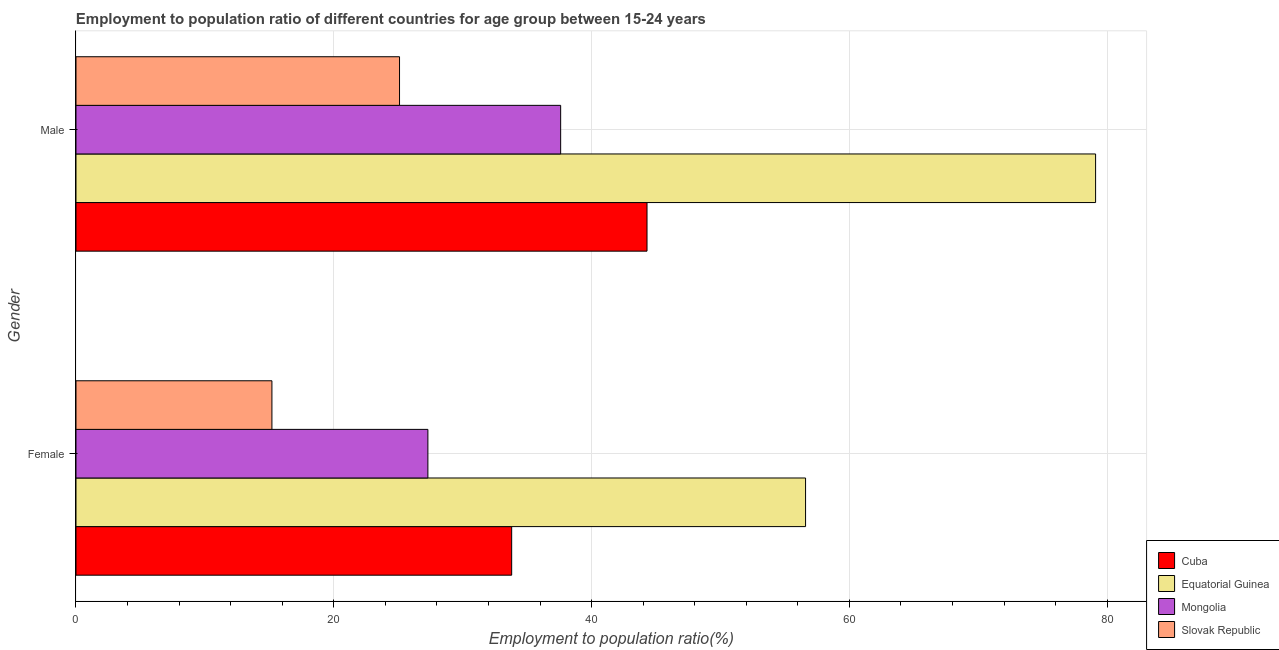How many groups of bars are there?
Provide a succinct answer. 2. How many bars are there on the 1st tick from the top?
Offer a terse response. 4. What is the employment to population ratio(female) in Cuba?
Offer a very short reply. 33.8. Across all countries, what is the maximum employment to population ratio(male)?
Make the answer very short. 79.1. Across all countries, what is the minimum employment to population ratio(male)?
Keep it short and to the point. 25.1. In which country was the employment to population ratio(female) maximum?
Your answer should be very brief. Equatorial Guinea. In which country was the employment to population ratio(male) minimum?
Make the answer very short. Slovak Republic. What is the total employment to population ratio(male) in the graph?
Your response must be concise. 186.1. What is the difference between the employment to population ratio(female) in Mongolia and that in Cuba?
Offer a terse response. -6.5. What is the difference between the employment to population ratio(male) in Mongolia and the employment to population ratio(female) in Equatorial Guinea?
Keep it short and to the point. -19. What is the average employment to population ratio(female) per country?
Your response must be concise. 33.22. What is the difference between the employment to population ratio(female) and employment to population ratio(male) in Equatorial Guinea?
Provide a succinct answer. -22.5. What is the ratio of the employment to population ratio(female) in Slovak Republic to that in Equatorial Guinea?
Give a very brief answer. 0.27. In how many countries, is the employment to population ratio(female) greater than the average employment to population ratio(female) taken over all countries?
Make the answer very short. 2. What does the 4th bar from the top in Female represents?
Your answer should be very brief. Cuba. What does the 4th bar from the bottom in Male represents?
Give a very brief answer. Slovak Republic. Are the values on the major ticks of X-axis written in scientific E-notation?
Your response must be concise. No. How are the legend labels stacked?
Provide a succinct answer. Vertical. What is the title of the graph?
Provide a short and direct response. Employment to population ratio of different countries for age group between 15-24 years. What is the label or title of the X-axis?
Your answer should be very brief. Employment to population ratio(%). What is the label or title of the Y-axis?
Keep it short and to the point. Gender. What is the Employment to population ratio(%) of Cuba in Female?
Your response must be concise. 33.8. What is the Employment to population ratio(%) of Equatorial Guinea in Female?
Provide a succinct answer. 56.6. What is the Employment to population ratio(%) of Mongolia in Female?
Offer a terse response. 27.3. What is the Employment to population ratio(%) in Slovak Republic in Female?
Your answer should be compact. 15.2. What is the Employment to population ratio(%) of Cuba in Male?
Make the answer very short. 44.3. What is the Employment to population ratio(%) of Equatorial Guinea in Male?
Provide a short and direct response. 79.1. What is the Employment to population ratio(%) of Mongolia in Male?
Give a very brief answer. 37.6. What is the Employment to population ratio(%) of Slovak Republic in Male?
Keep it short and to the point. 25.1. Across all Gender, what is the maximum Employment to population ratio(%) of Cuba?
Your response must be concise. 44.3. Across all Gender, what is the maximum Employment to population ratio(%) of Equatorial Guinea?
Provide a short and direct response. 79.1. Across all Gender, what is the maximum Employment to population ratio(%) in Mongolia?
Give a very brief answer. 37.6. Across all Gender, what is the maximum Employment to population ratio(%) of Slovak Republic?
Make the answer very short. 25.1. Across all Gender, what is the minimum Employment to population ratio(%) in Cuba?
Offer a very short reply. 33.8. Across all Gender, what is the minimum Employment to population ratio(%) in Equatorial Guinea?
Your answer should be very brief. 56.6. Across all Gender, what is the minimum Employment to population ratio(%) of Mongolia?
Offer a terse response. 27.3. Across all Gender, what is the minimum Employment to population ratio(%) in Slovak Republic?
Provide a short and direct response. 15.2. What is the total Employment to population ratio(%) of Cuba in the graph?
Give a very brief answer. 78.1. What is the total Employment to population ratio(%) of Equatorial Guinea in the graph?
Offer a terse response. 135.7. What is the total Employment to population ratio(%) in Mongolia in the graph?
Your response must be concise. 64.9. What is the total Employment to population ratio(%) in Slovak Republic in the graph?
Your answer should be compact. 40.3. What is the difference between the Employment to population ratio(%) of Equatorial Guinea in Female and that in Male?
Give a very brief answer. -22.5. What is the difference between the Employment to population ratio(%) in Slovak Republic in Female and that in Male?
Offer a terse response. -9.9. What is the difference between the Employment to population ratio(%) in Cuba in Female and the Employment to population ratio(%) in Equatorial Guinea in Male?
Your response must be concise. -45.3. What is the difference between the Employment to population ratio(%) in Cuba in Female and the Employment to population ratio(%) in Mongolia in Male?
Ensure brevity in your answer.  -3.8. What is the difference between the Employment to population ratio(%) of Equatorial Guinea in Female and the Employment to population ratio(%) of Slovak Republic in Male?
Your answer should be very brief. 31.5. What is the average Employment to population ratio(%) of Cuba per Gender?
Offer a terse response. 39.05. What is the average Employment to population ratio(%) in Equatorial Guinea per Gender?
Provide a short and direct response. 67.85. What is the average Employment to population ratio(%) in Mongolia per Gender?
Provide a short and direct response. 32.45. What is the average Employment to population ratio(%) in Slovak Republic per Gender?
Offer a very short reply. 20.15. What is the difference between the Employment to population ratio(%) of Cuba and Employment to population ratio(%) of Equatorial Guinea in Female?
Give a very brief answer. -22.8. What is the difference between the Employment to population ratio(%) of Cuba and Employment to population ratio(%) of Mongolia in Female?
Your answer should be very brief. 6.5. What is the difference between the Employment to population ratio(%) in Cuba and Employment to population ratio(%) in Slovak Republic in Female?
Ensure brevity in your answer.  18.6. What is the difference between the Employment to population ratio(%) in Equatorial Guinea and Employment to population ratio(%) in Mongolia in Female?
Offer a terse response. 29.3. What is the difference between the Employment to population ratio(%) of Equatorial Guinea and Employment to population ratio(%) of Slovak Republic in Female?
Keep it short and to the point. 41.4. What is the difference between the Employment to population ratio(%) in Mongolia and Employment to population ratio(%) in Slovak Republic in Female?
Your answer should be very brief. 12.1. What is the difference between the Employment to population ratio(%) in Cuba and Employment to population ratio(%) in Equatorial Guinea in Male?
Your response must be concise. -34.8. What is the difference between the Employment to population ratio(%) of Cuba and Employment to population ratio(%) of Slovak Republic in Male?
Ensure brevity in your answer.  19.2. What is the difference between the Employment to population ratio(%) of Equatorial Guinea and Employment to population ratio(%) of Mongolia in Male?
Offer a very short reply. 41.5. What is the difference between the Employment to population ratio(%) in Equatorial Guinea and Employment to population ratio(%) in Slovak Republic in Male?
Provide a short and direct response. 54. What is the ratio of the Employment to population ratio(%) in Cuba in Female to that in Male?
Provide a short and direct response. 0.76. What is the ratio of the Employment to population ratio(%) in Equatorial Guinea in Female to that in Male?
Offer a terse response. 0.72. What is the ratio of the Employment to population ratio(%) of Mongolia in Female to that in Male?
Provide a succinct answer. 0.73. What is the ratio of the Employment to population ratio(%) of Slovak Republic in Female to that in Male?
Keep it short and to the point. 0.61. What is the difference between the highest and the second highest Employment to population ratio(%) of Equatorial Guinea?
Make the answer very short. 22.5. What is the difference between the highest and the second highest Employment to population ratio(%) in Mongolia?
Your answer should be compact. 10.3. What is the difference between the highest and the lowest Employment to population ratio(%) in Cuba?
Provide a short and direct response. 10.5. What is the difference between the highest and the lowest Employment to population ratio(%) of Mongolia?
Give a very brief answer. 10.3. What is the difference between the highest and the lowest Employment to population ratio(%) in Slovak Republic?
Ensure brevity in your answer.  9.9. 